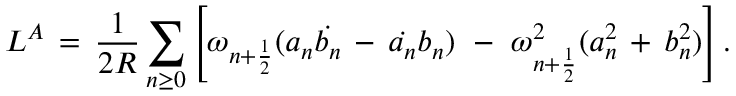Convert formula to latex. <formula><loc_0><loc_0><loc_500><loc_500>L ^ { A } \, = \, \frac { 1 } { 2 R } \sum _ { n \geq 0 } \left [ \omega _ { n + \frac { 1 } { 2 } } ( a _ { n } \dot { b _ { n } } \, - \, \dot { a _ { n } } b _ { n } ) \, - \, \omega _ { n + \frac { 1 } { 2 } } ^ { 2 } ( a _ { n } ^ { 2 } \, + \, b _ { n } ^ { 2 } ) \right ] .</formula> 